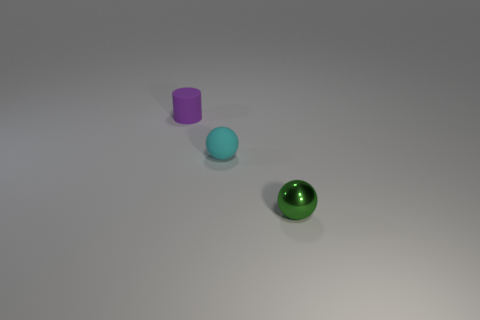Add 3 cyan rubber cylinders. How many objects exist? 6 Subtract all green spheres. How many spheres are left? 1 Subtract 2 spheres. How many spheres are left? 0 Subtract all cylinders. How many objects are left? 2 Subtract all purple balls. Subtract all blue cylinders. How many balls are left? 2 Subtract all tiny cyan rubber objects. Subtract all small rubber balls. How many objects are left? 1 Add 2 small purple matte things. How many small purple matte things are left? 3 Add 3 tiny metal spheres. How many tiny metal spheres exist? 4 Subtract 1 purple cylinders. How many objects are left? 2 